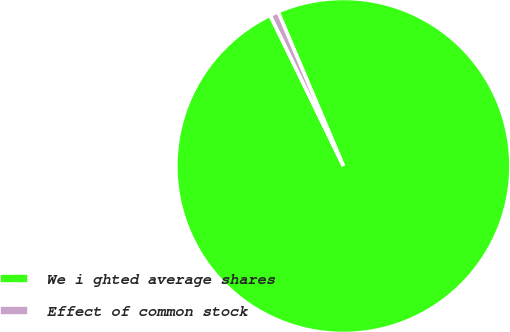<chart> <loc_0><loc_0><loc_500><loc_500><pie_chart><fcel>We i ghted average shares<fcel>Effect of common stock<nl><fcel>99.18%<fcel>0.82%<nl></chart> 